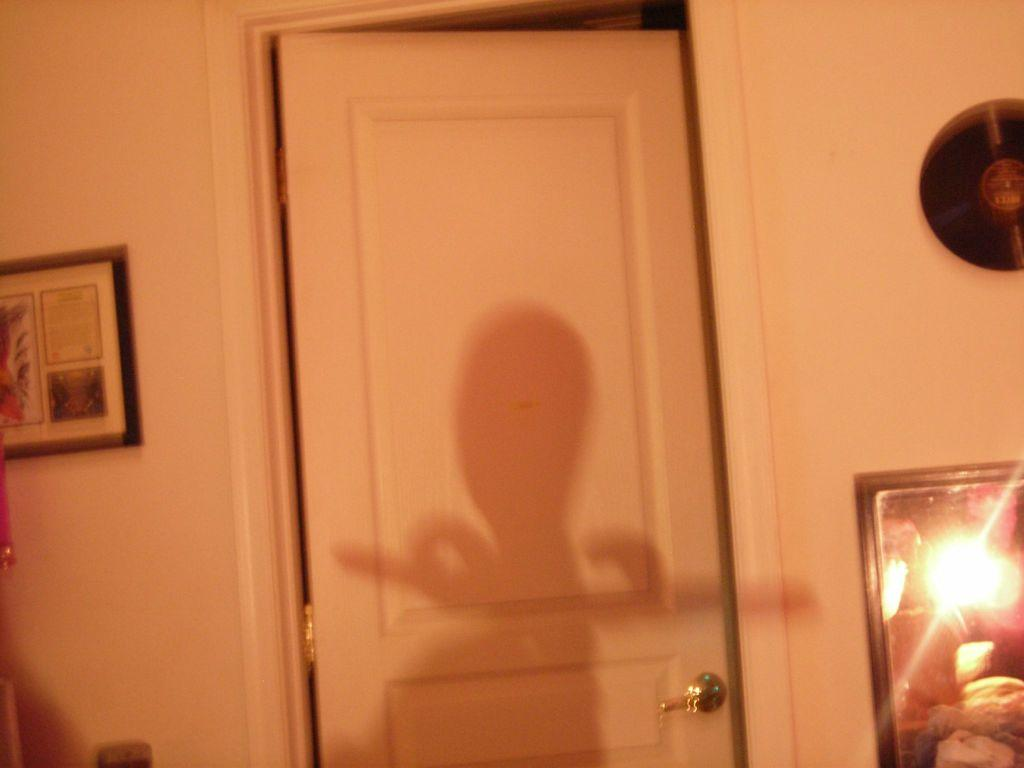What type of structure can be seen in the image? There is a wall in the image. What is hanging on the wall? There is a photo frame in the image. Is there any entrance or exit visible in the image? Yes, there is a door in the image. What can be used for personal grooming or checking appearance in the image? There is a mirror in the image. What is the aftermath of the son's actions in the image? There is no son or any actions mentioned in the image, so it is not possible to determine the aftermath. 